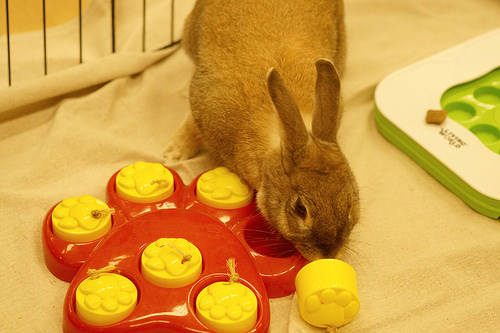<image>
Can you confirm if the rabbit is on the yellow toy? Yes. Looking at the image, I can see the rabbit is positioned on top of the yellow toy, with the yellow toy providing support. Is there a rabbit to the right of the barrier? Yes. From this viewpoint, the rabbit is positioned to the right side relative to the barrier. Where is the rabbit in relation to the floormat? Is it next to the floormat? Yes. The rabbit is positioned adjacent to the floormat, located nearby in the same general area. 